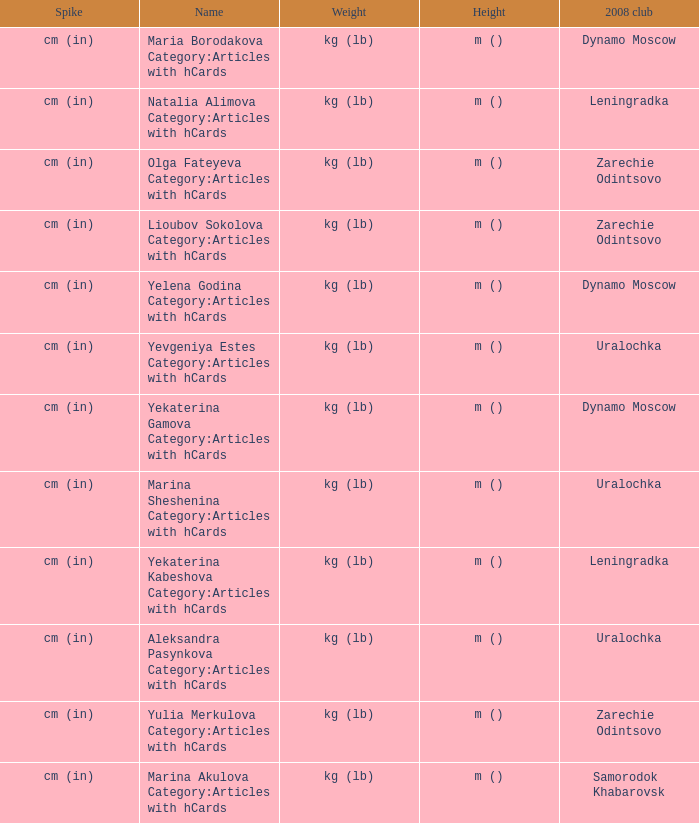What is the name when the 2008 club is uralochka? Yevgeniya Estes Category:Articles with hCards, Marina Sheshenina Category:Articles with hCards, Aleksandra Pasynkova Category:Articles with hCards. 